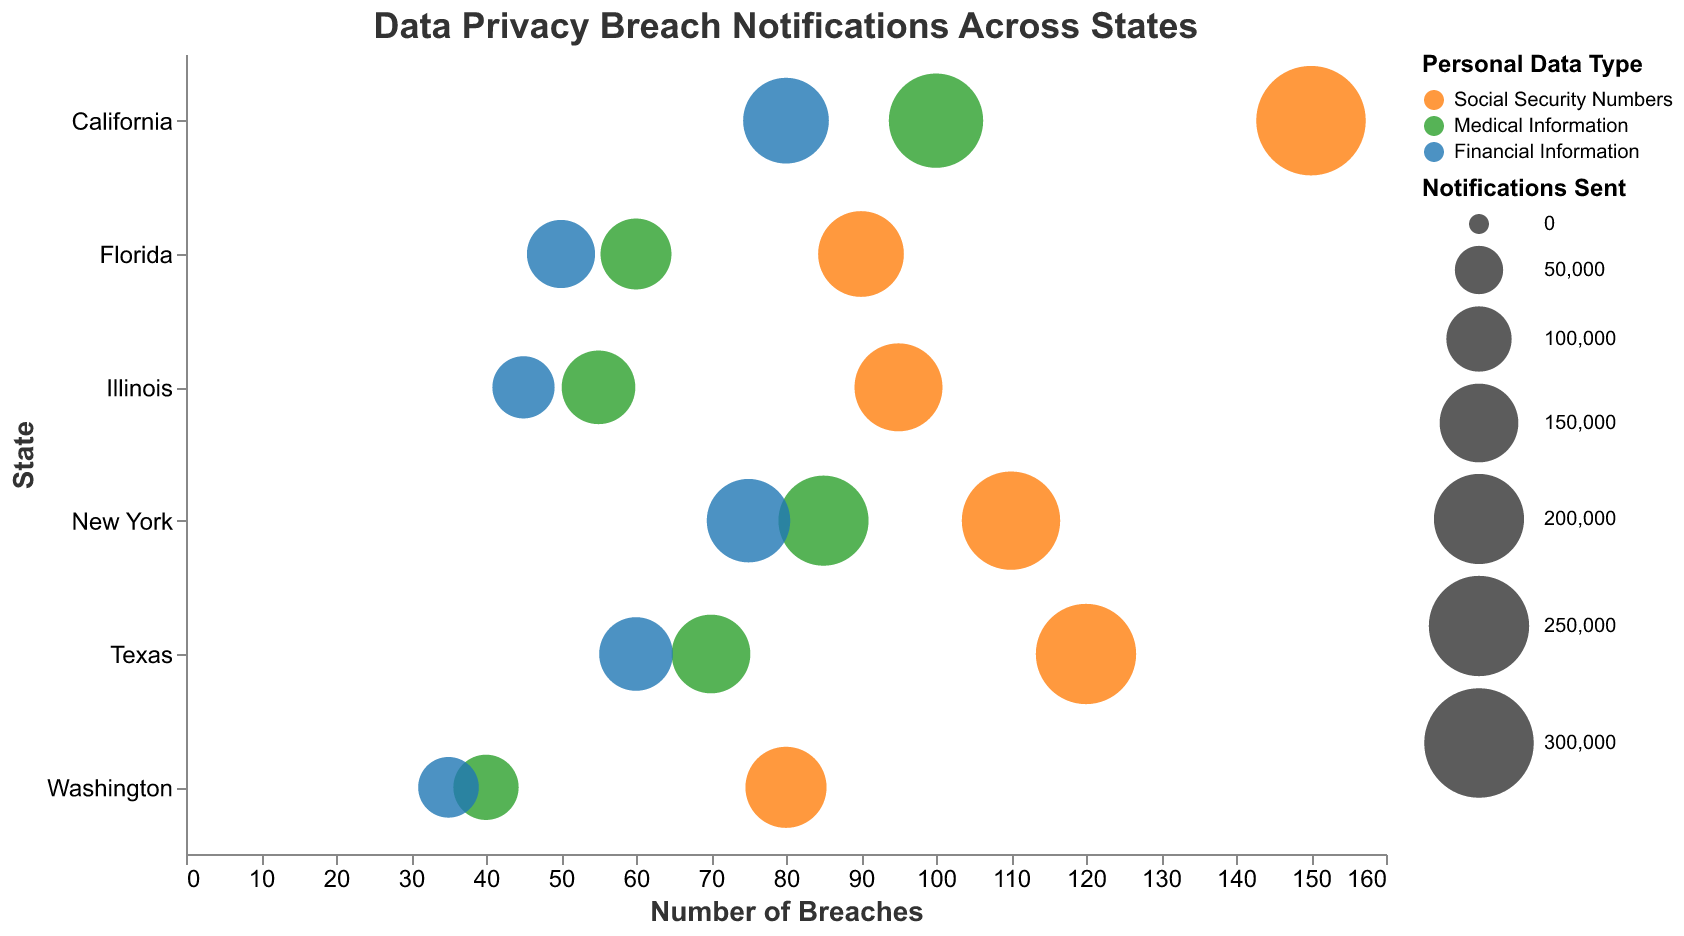What is the title of the figure? The title of the figure is displayed prominently at the top and reads "Data Privacy Breach Notifications Across States".
Answer: Data Privacy Breach Notifications Across States Which state has the highest number of breaches for Social Security Numbers? According to the chart, California has the highest number of breaches for Social Security Numbers with 150 breaches.
Answer: California How many notifications were sent for financial information breaches in Illinois? By looking at the bubbles for Illinois and identifying the color corresponding to Financial Information, we see that 90,000 notifications were sent.
Answer: 90,000 Compare the number of breaches for medical information between New York and Texas. New York has 85 breaches for medical information, while Texas has 70 breaches. So, New York has 15 more breaches than Texas for medical information.
Answer: 15 Which state has the smallest number of breaches for any type of personal data? The smallest number of breaches for any type of personal data is 35, which occurs for financial information in Washington.
Answer: Washington What is the total number of breaches for Social Security Numbers across all states? Adding the number of breaches for Social Security Numbers from all states: 150 (CA) + 120 (TX) + 90 (FL) + 110 (NY) + 95 (IL) + 80 (WA) equals 645 breaches.
Answer: 645 Is there any state where medical information breaches have triggered more than 200,000 notifications? In California, medical information breaches have resulted in 220,000 notifications, which is more than 200,000.
Answer: Yes, California What is the average number of breaches for financial information across all states? Adding up the number of breaches for financial information: 80 (CA) + 60 (TX) + 50 (FL) + 75 (NY) + 45 (IL) + 35 (WA) gives 345. Dividing by the 6 states, the average is 345/6 which is approximately 57.5 breaches.
Answer: 57.5 How does the number of notifications sent in Florida for Social Security Numbers compare to that for Medical Information? In Florida, there were 180,000 notifications sent for Social Security Numbers and 120,000 for Medical Information. There are 60,000 more notifications for Social Security Numbers.
Answer: 60,000 more Which data type in California results in the smallest number of notifications being sent? In California, the smallest number of notifications sent is for financial information breaches, which is 180,000.
Answer: Financial Information 